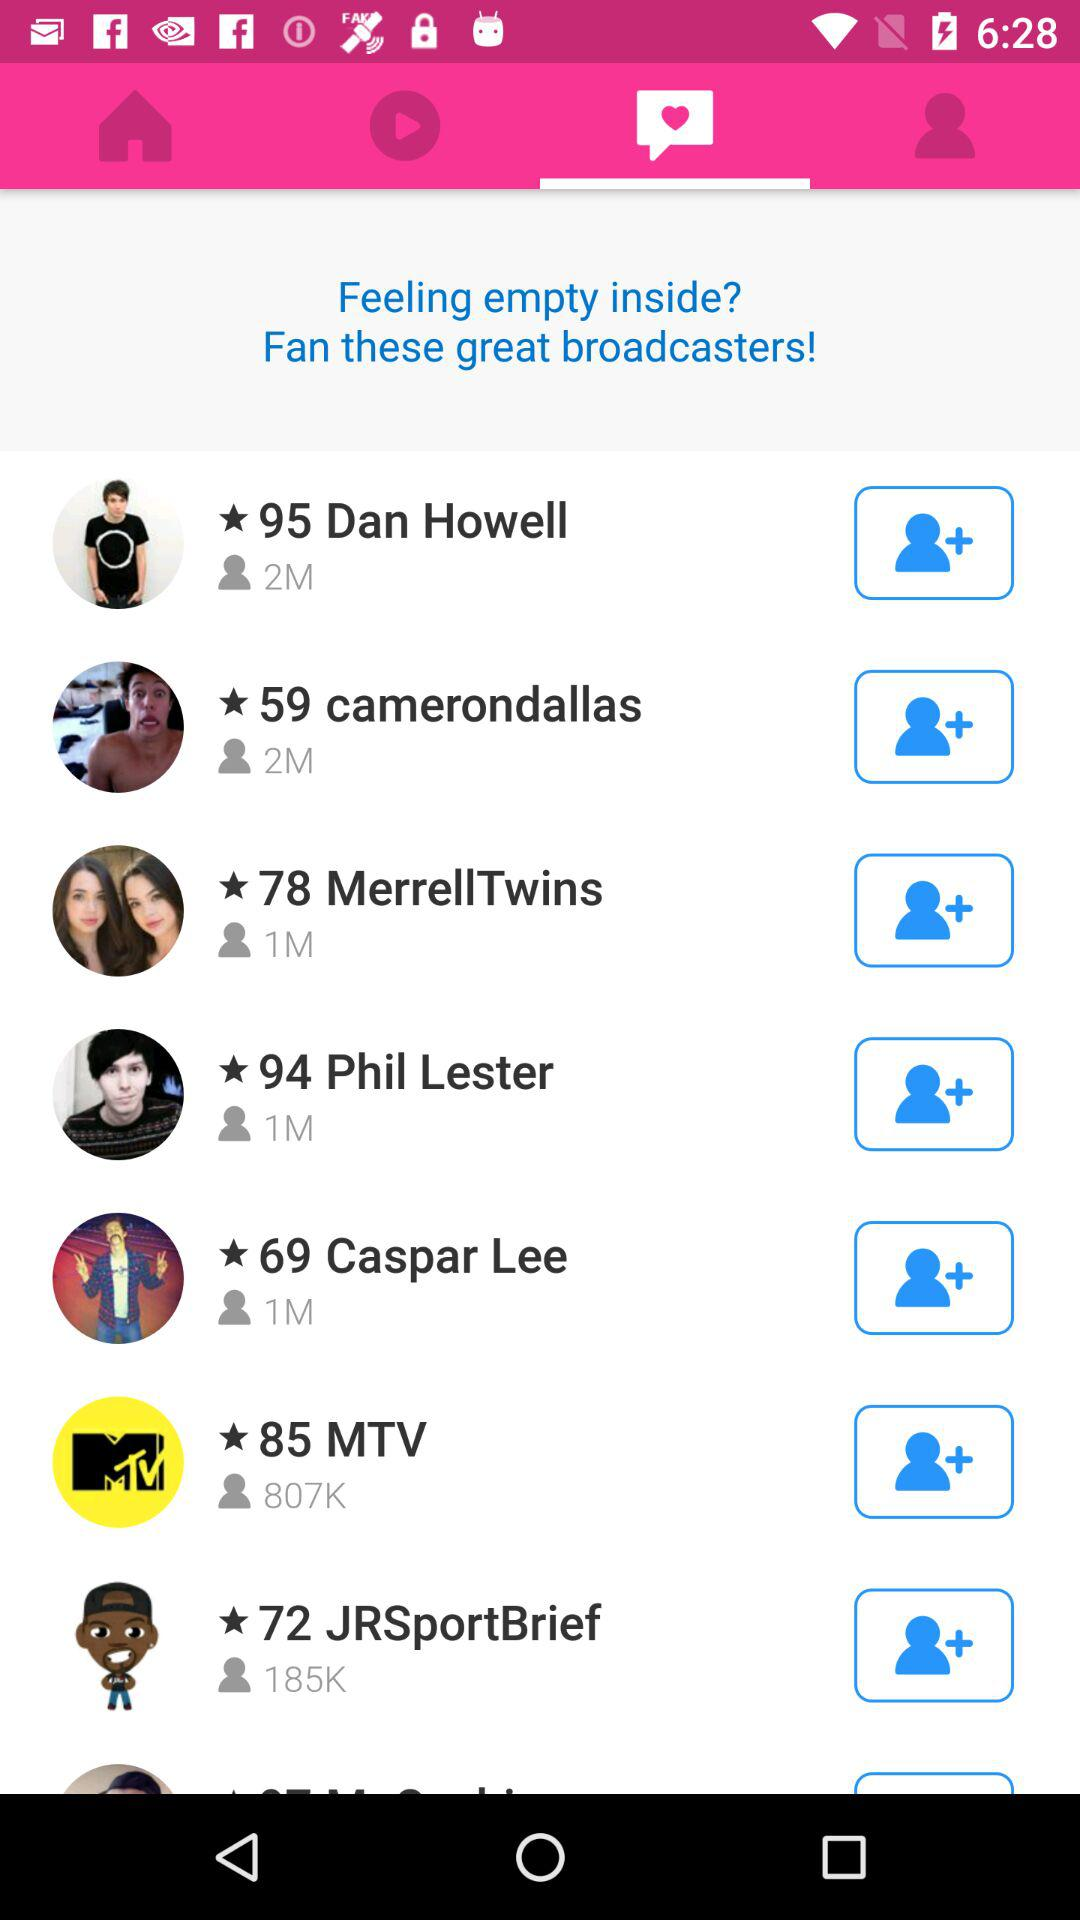How many views are there for 95 Dan Howell? The views there for 95 Dan Howell are 2M. 